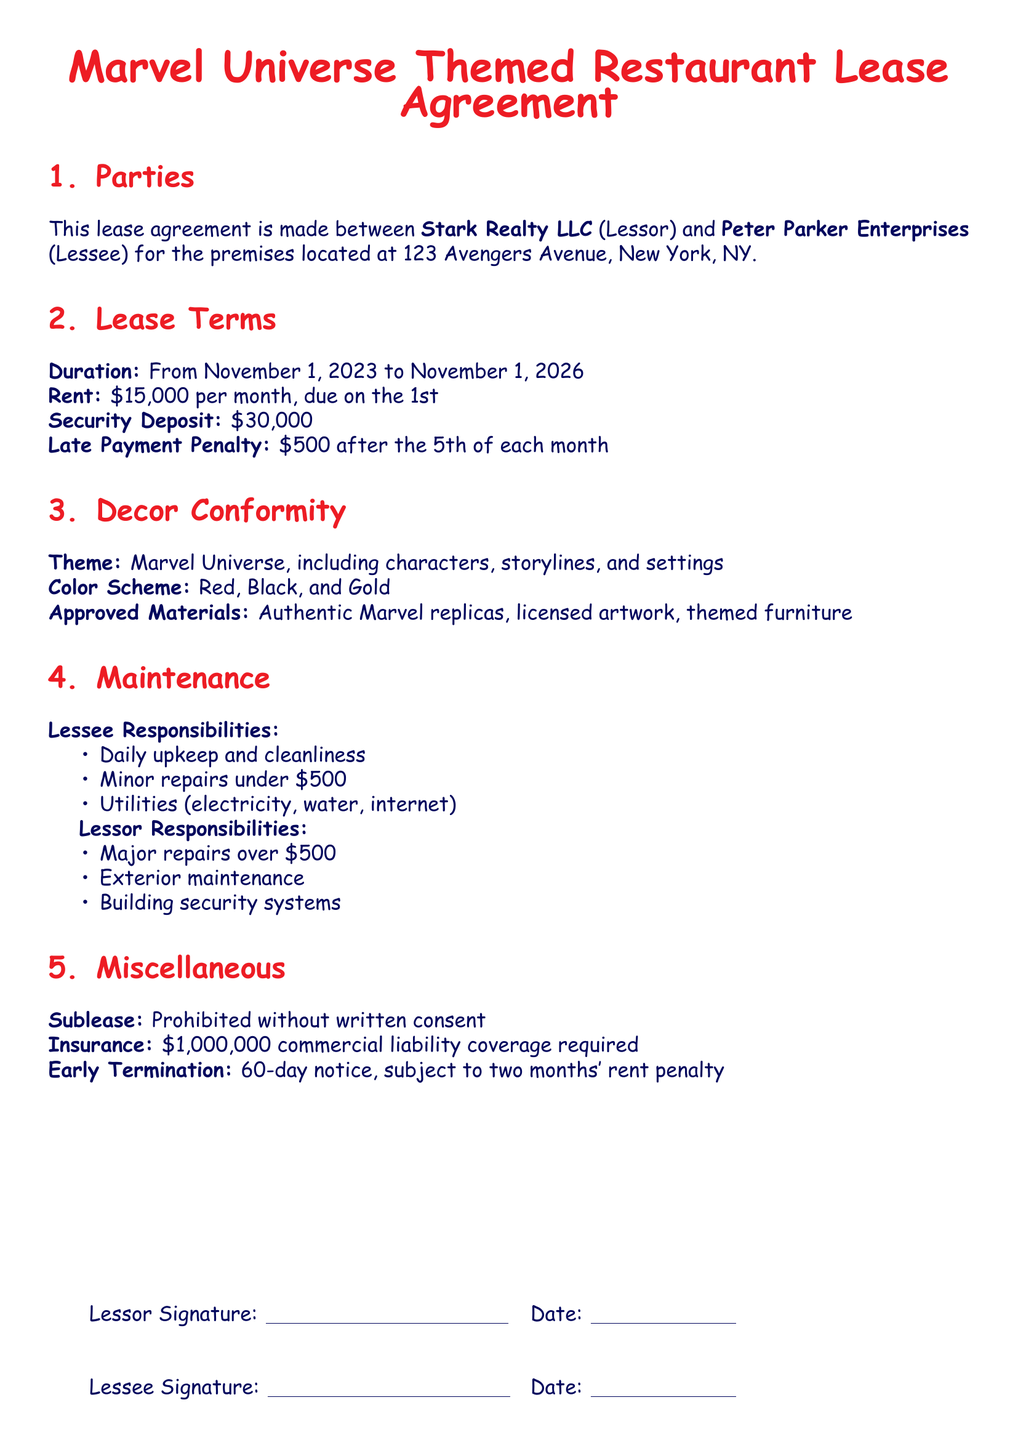What is the lease duration? The lease duration is stated in the document, spanning three years from November 1, 2023, to November 1, 2026.
Answer: From November 1, 2023 to November 1, 2026 What is the monthly rent? The document specifies that the monthly rent for the premises is set at a specific amount due on the first of each month.
Answer: $15,000 What is the security deposit amount? The security deposit is explicitly mentioned in the document, which outlines the financial obligations of the lessee.
Answer: $30,000 What are the approved materials for decor? The document lists specific materials that are allowed for the restaurant's theme, indicating a focus on authenticity and licensing.
Answer: Authentic Marvel replicas, licensed artwork, themed furniture Who is responsible for major repairs? The responsibilities for various types of repairs are delineated in the document, specifying which party handles major maintenance activities.
Answer: Lessor What color scheme is required? The document establishes a specific color scheme that aligns with the themed decor, emphasizing consistency with the overall Marvel theme.
Answer: Red, Black, and Gold What is the penalty for late payment? The document outlines the consequences of not paying rent on time, providing clarity on financial penalties associated with late payments.
Answer: $500 after the 5th of each month Is subleasing allowed? The lease agreement specifies conditions regarding subleasing, clarifying the expectations and limitations within the contract.
Answer: Prohibited without written consent What is the required insurance coverage? The insurance requirements are clearly stated in the document, outlining the necessary financial protection for the lessee.
Answer: $1,000,000 commercial liability coverage required 